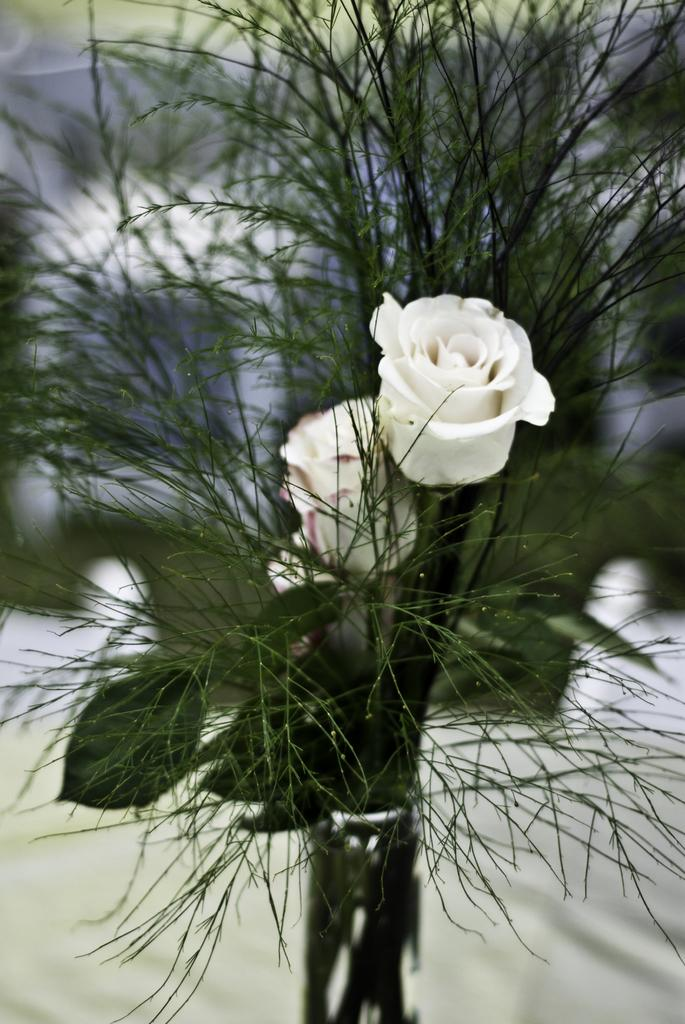What is the main subject of the image? The main subject of the image is a flower bouquet. Can you describe the flower bouquet in the image? The flower bouquet consists of various types of flowers arranged together. What type of cloud can be seen in the image? There is no cloud present in the image, as the main subject is a flower bouquet. Is there a snail crawling on the flowers in the image? There is no snail visible in the image; it only features a flower bouquet. 